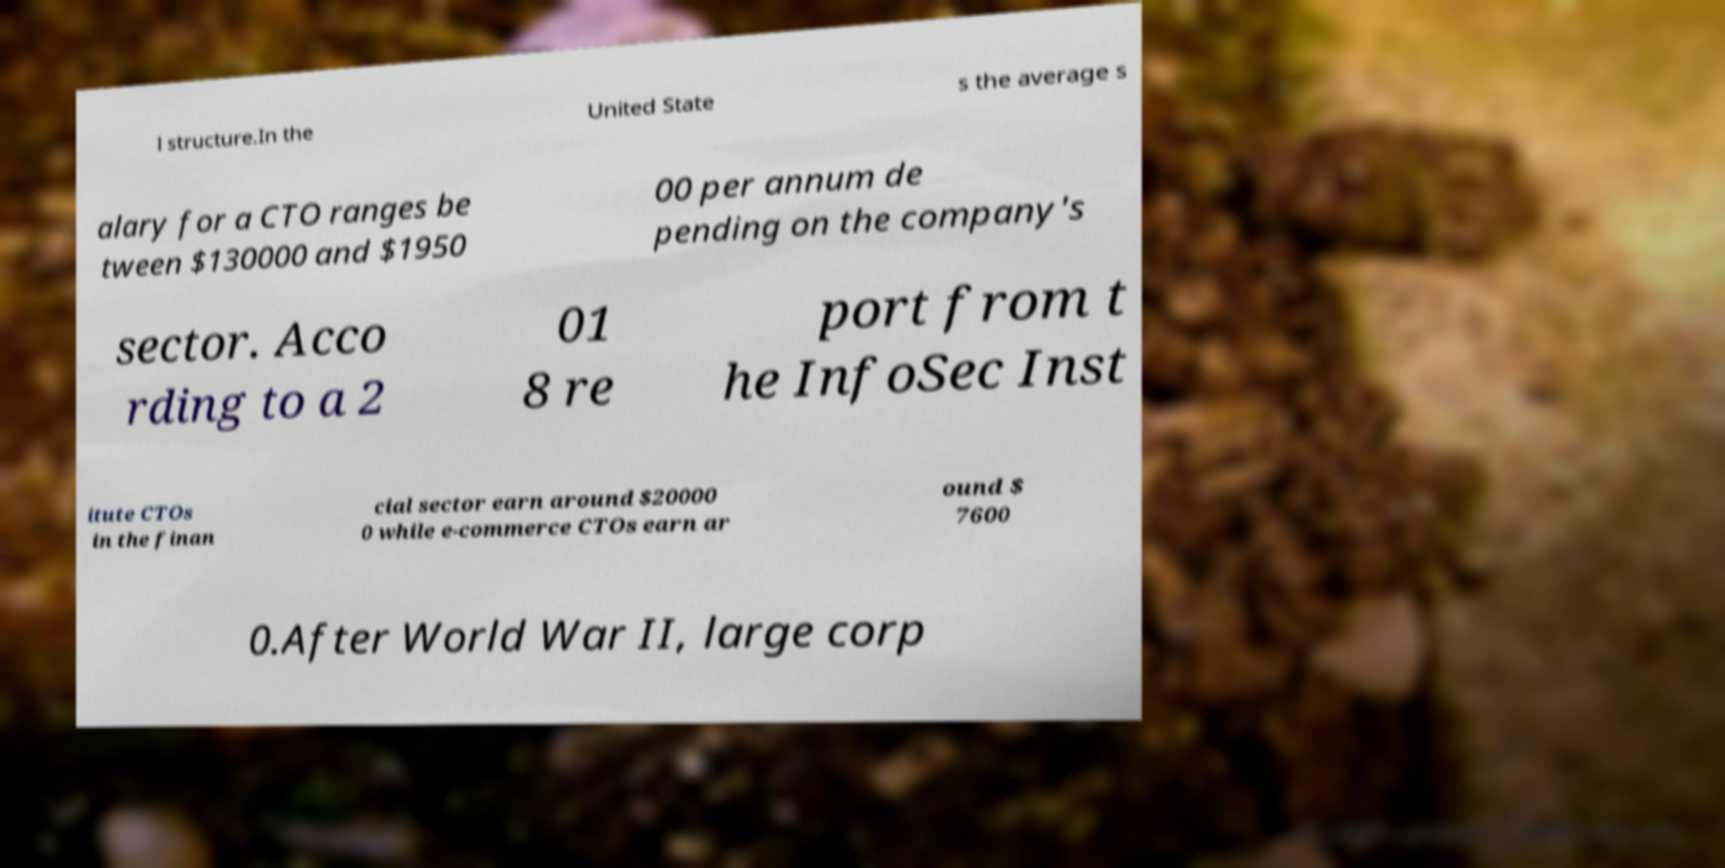Please identify and transcribe the text found in this image. l structure.In the United State s the average s alary for a CTO ranges be tween $130000 and $1950 00 per annum de pending on the company's sector. Acco rding to a 2 01 8 re port from t he InfoSec Inst itute CTOs in the finan cial sector earn around $20000 0 while e-commerce CTOs earn ar ound $ 7600 0.After World War II, large corp 